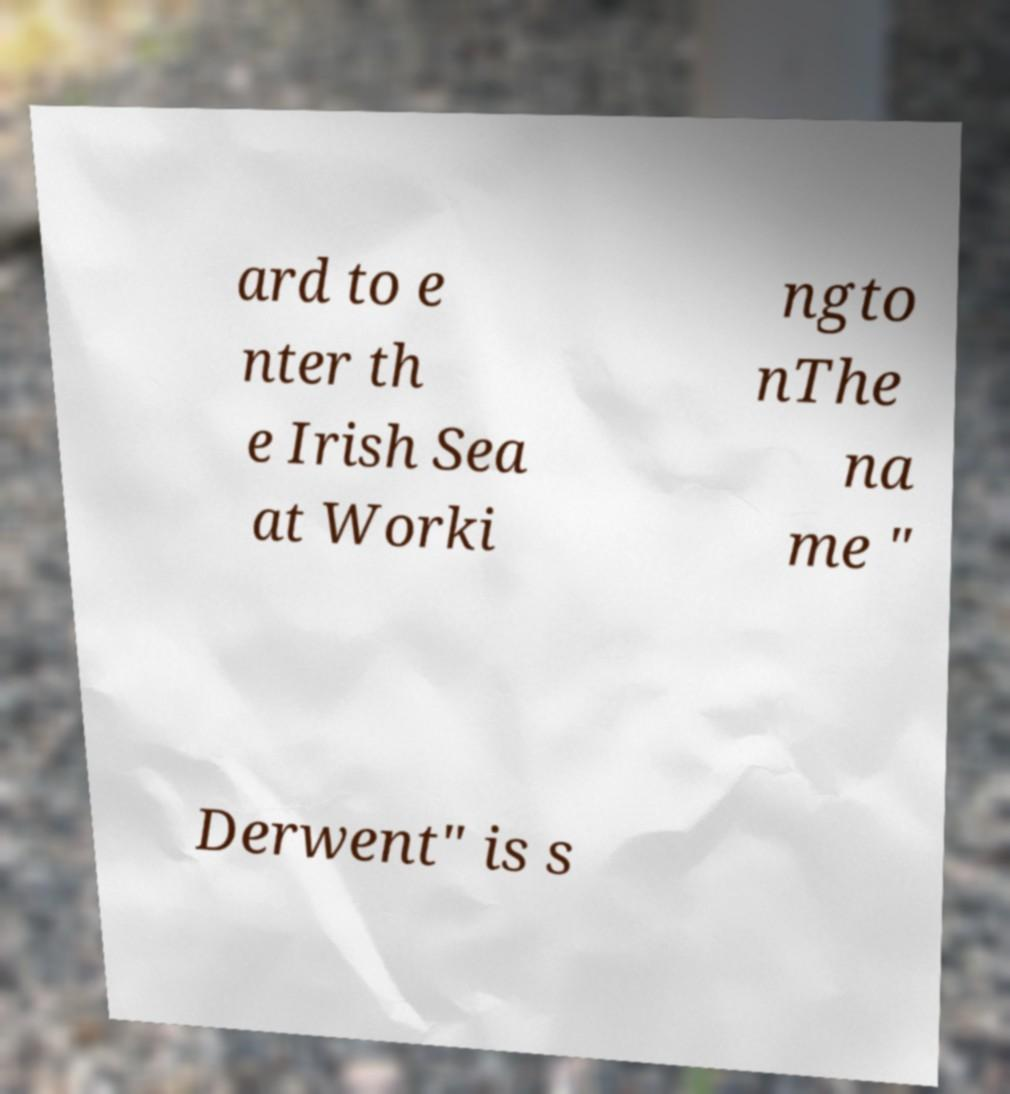What messages or text are displayed in this image? I need them in a readable, typed format. ard to e nter th e Irish Sea at Worki ngto nThe na me " Derwent" is s 